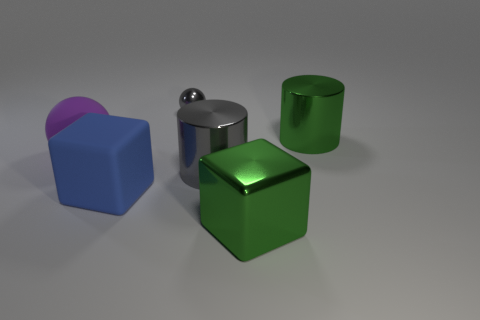Add 3 big blocks. How many objects exist? 9 Subtract all cylinders. How many objects are left? 4 Subtract 0 red cubes. How many objects are left? 6 Subtract all yellow rubber spheres. Subtract all big purple rubber things. How many objects are left? 5 Add 2 small gray shiny balls. How many small gray shiny balls are left? 3 Add 3 purple metal blocks. How many purple metal blocks exist? 3 